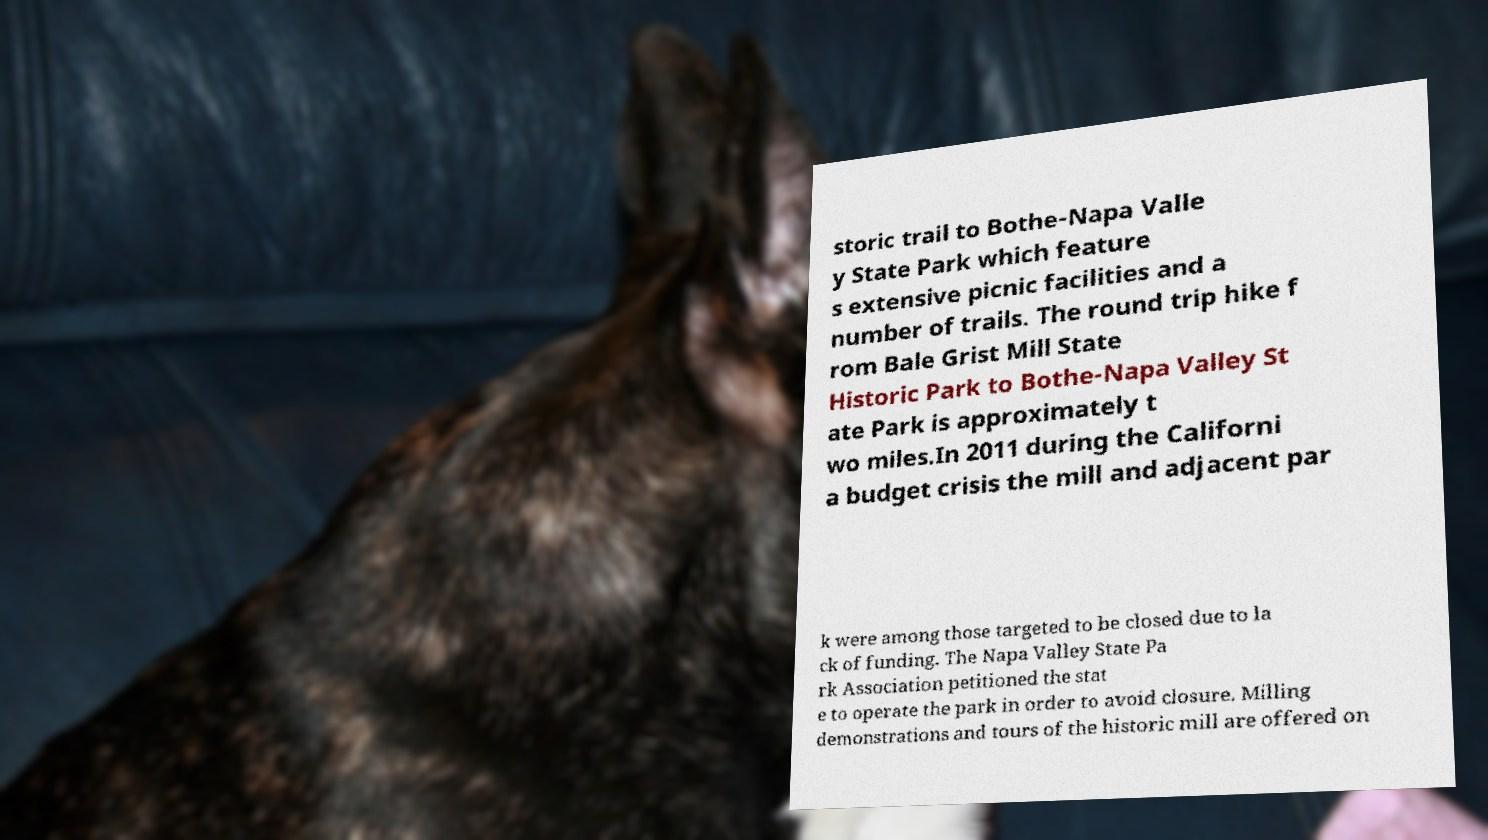I need the written content from this picture converted into text. Can you do that? storic trail to Bothe-Napa Valle y State Park which feature s extensive picnic facilities and a number of trails. The round trip hike f rom Bale Grist Mill State Historic Park to Bothe-Napa Valley St ate Park is approximately t wo miles.In 2011 during the Californi a budget crisis the mill and adjacent par k were among those targeted to be closed due to la ck of funding. The Napa Valley State Pa rk Association petitioned the stat e to operate the park in order to avoid closure. Milling demonstrations and tours of the historic mill are offered on 